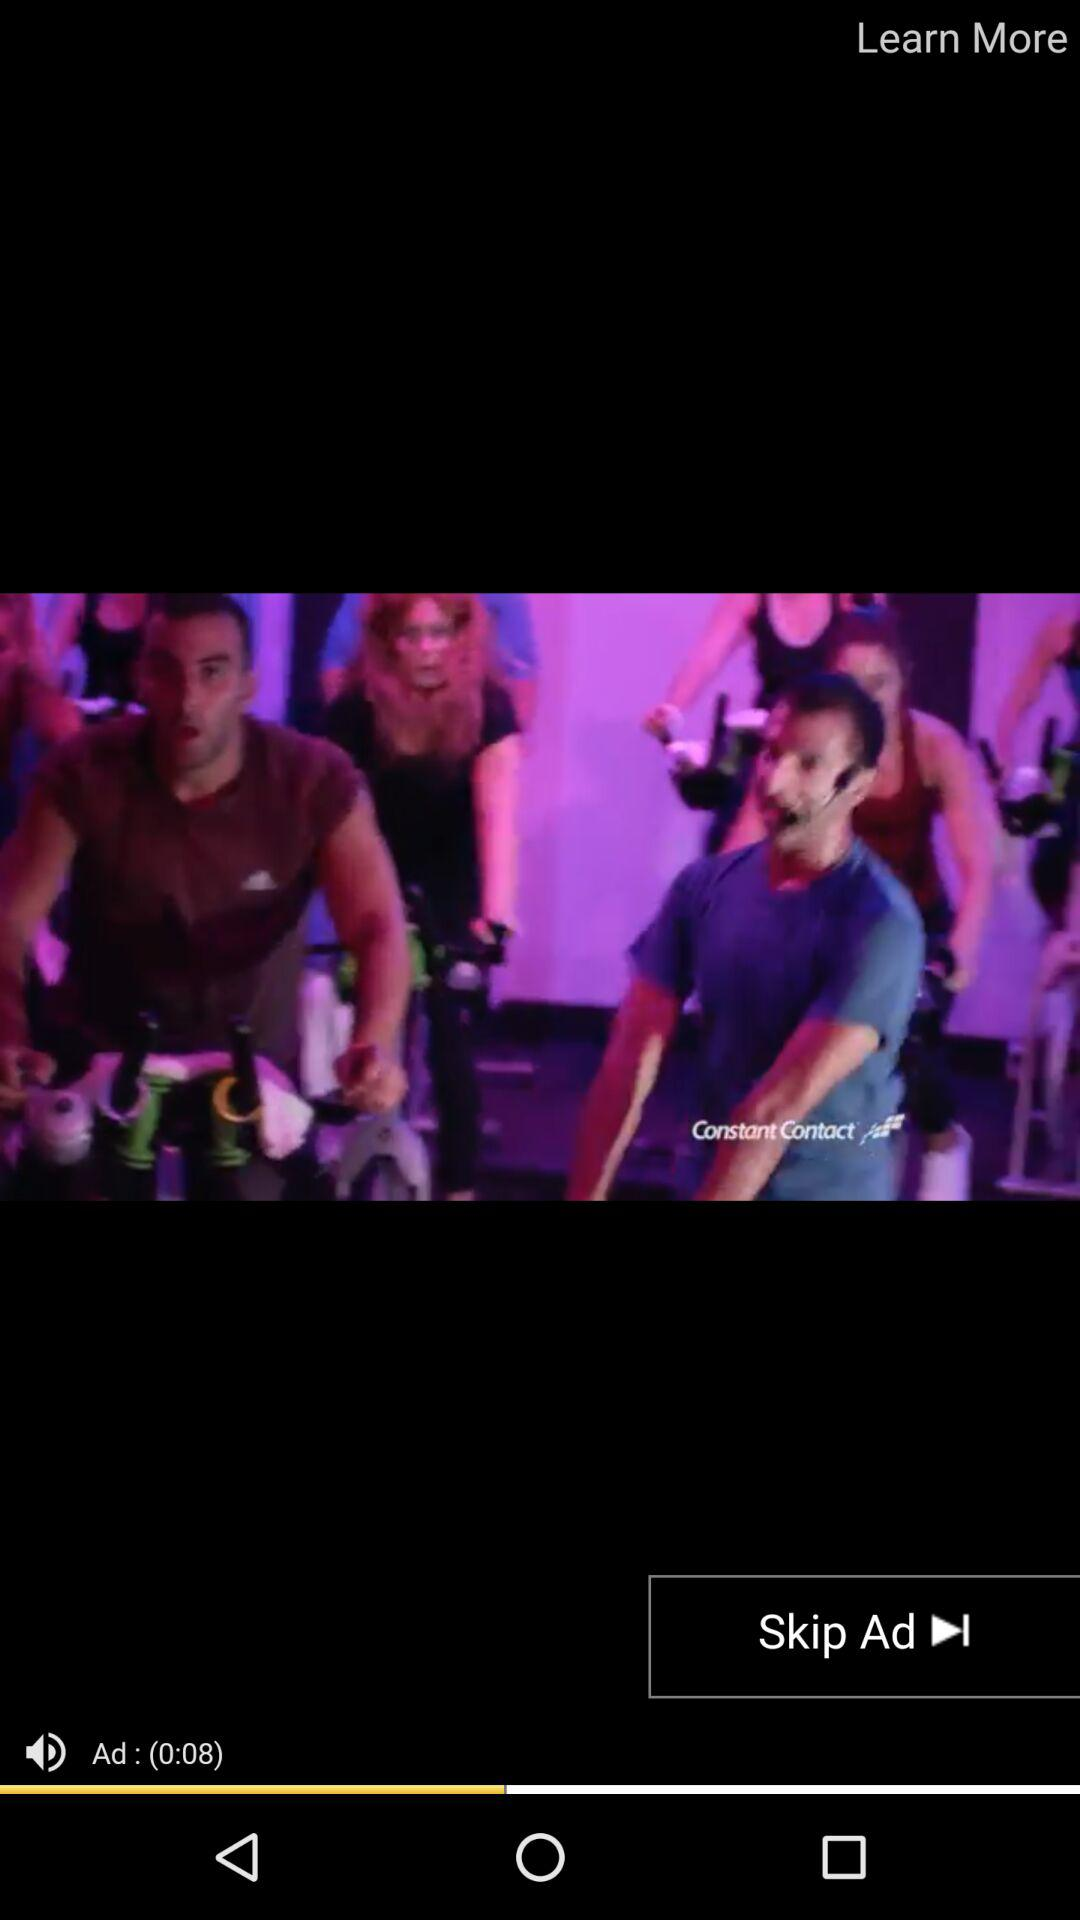How many seconds long is the ad?
Answer the question using a single word or phrase. 8 